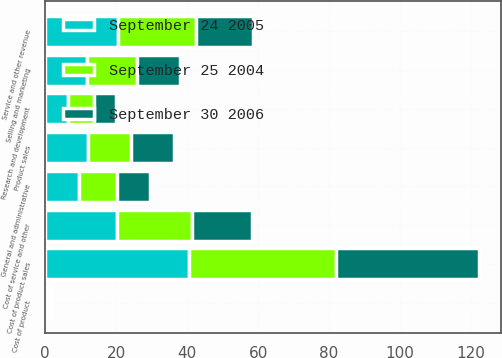Convert chart to OTSL. <chart><loc_0><loc_0><loc_500><loc_500><stacked_bar_chart><ecel><fcel>Product sales<fcel>Service and other revenue<fcel>Cost of product sales<fcel>Cost of product<fcel>Cost of service and other<fcel>Research and development<fcel>Selling and marketing<fcel>General and administrative<nl><fcel>September 30 2006<fcel>12.1<fcel>16.1<fcel>40.4<fcel>1<fcel>16.8<fcel>6.1<fcel>12.1<fcel>9.2<nl><fcel>September 24 2005<fcel>12.1<fcel>20.4<fcel>40.5<fcel>0.3<fcel>20.2<fcel>6.5<fcel>11.9<fcel>9.6<nl><fcel>September 25 2004<fcel>12.1<fcel>22.2<fcel>41.4<fcel>0.4<fcel>21.2<fcel>7.3<fcel>13.9<fcel>10.7<nl></chart> 